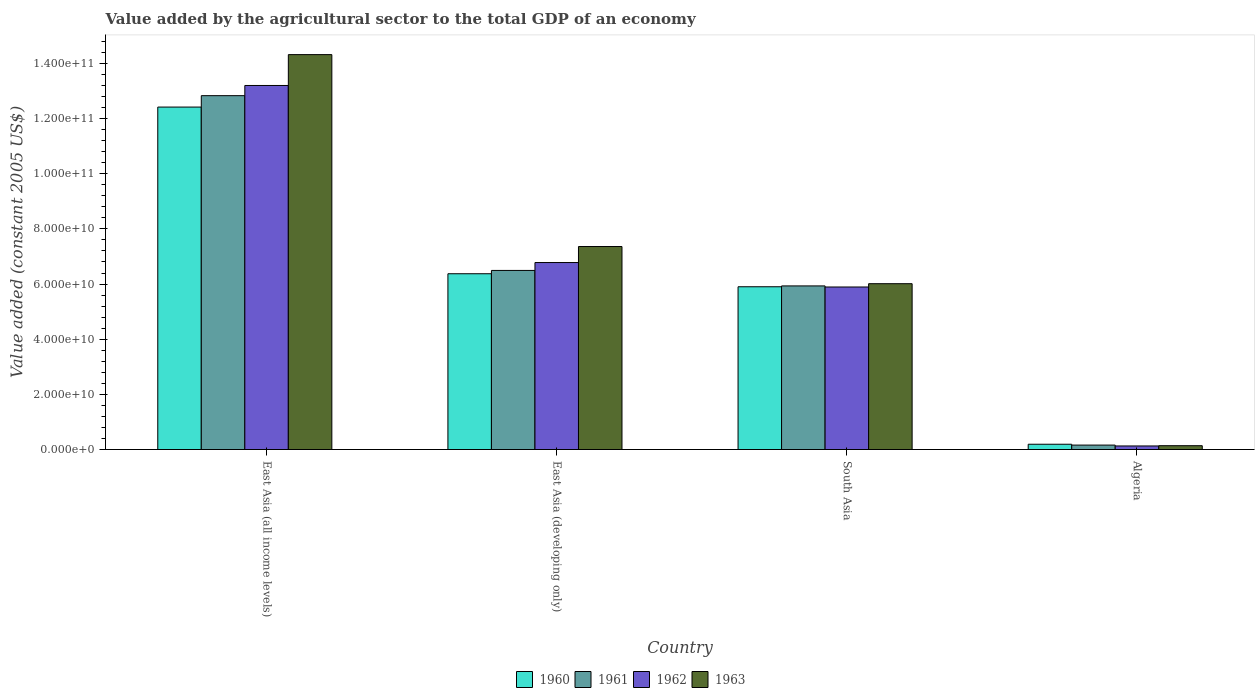Are the number of bars per tick equal to the number of legend labels?
Provide a short and direct response. Yes. What is the label of the 2nd group of bars from the left?
Your response must be concise. East Asia (developing only). In how many cases, is the number of bars for a given country not equal to the number of legend labels?
Provide a short and direct response. 0. What is the value added by the agricultural sector in 1960 in South Asia?
Your response must be concise. 5.90e+1. Across all countries, what is the maximum value added by the agricultural sector in 1961?
Offer a terse response. 1.28e+11. Across all countries, what is the minimum value added by the agricultural sector in 1961?
Ensure brevity in your answer.  1.61e+09. In which country was the value added by the agricultural sector in 1962 maximum?
Your answer should be very brief. East Asia (all income levels). In which country was the value added by the agricultural sector in 1961 minimum?
Keep it short and to the point. Algeria. What is the total value added by the agricultural sector in 1962 in the graph?
Offer a terse response. 2.60e+11. What is the difference between the value added by the agricultural sector in 1960 in East Asia (all income levels) and that in South Asia?
Your answer should be very brief. 6.51e+1. What is the difference between the value added by the agricultural sector in 1962 in East Asia (all income levels) and the value added by the agricultural sector in 1960 in East Asia (developing only)?
Your answer should be very brief. 6.83e+1. What is the average value added by the agricultural sector in 1960 per country?
Keep it short and to the point. 6.22e+1. What is the difference between the value added by the agricultural sector of/in 1963 and value added by the agricultural sector of/in 1962 in East Asia (all income levels)?
Make the answer very short. 1.12e+1. What is the ratio of the value added by the agricultural sector in 1961 in Algeria to that in South Asia?
Make the answer very short. 0.03. Is the difference between the value added by the agricultural sector in 1963 in East Asia (all income levels) and East Asia (developing only) greater than the difference between the value added by the agricultural sector in 1962 in East Asia (all income levels) and East Asia (developing only)?
Ensure brevity in your answer.  Yes. What is the difference between the highest and the second highest value added by the agricultural sector in 1960?
Offer a terse response. 6.04e+1. What is the difference between the highest and the lowest value added by the agricultural sector in 1960?
Give a very brief answer. 1.22e+11. Is it the case that in every country, the sum of the value added by the agricultural sector in 1962 and value added by the agricultural sector in 1960 is greater than the sum of value added by the agricultural sector in 1963 and value added by the agricultural sector in 1961?
Make the answer very short. No. What does the 4th bar from the left in East Asia (all income levels) represents?
Your answer should be very brief. 1963. What does the 4th bar from the right in Algeria represents?
Ensure brevity in your answer.  1960. How many bars are there?
Provide a succinct answer. 16. How many countries are there in the graph?
Make the answer very short. 4. What is the difference between two consecutive major ticks on the Y-axis?
Offer a terse response. 2.00e+1. Does the graph contain grids?
Make the answer very short. No. How many legend labels are there?
Make the answer very short. 4. What is the title of the graph?
Provide a short and direct response. Value added by the agricultural sector to the total GDP of an economy. Does "1967" appear as one of the legend labels in the graph?
Your response must be concise. No. What is the label or title of the X-axis?
Offer a very short reply. Country. What is the label or title of the Y-axis?
Your answer should be very brief. Value added (constant 2005 US$). What is the Value added (constant 2005 US$) of 1960 in East Asia (all income levels)?
Give a very brief answer. 1.24e+11. What is the Value added (constant 2005 US$) in 1961 in East Asia (all income levels)?
Make the answer very short. 1.28e+11. What is the Value added (constant 2005 US$) in 1962 in East Asia (all income levels)?
Provide a succinct answer. 1.32e+11. What is the Value added (constant 2005 US$) of 1963 in East Asia (all income levels)?
Ensure brevity in your answer.  1.43e+11. What is the Value added (constant 2005 US$) in 1960 in East Asia (developing only)?
Ensure brevity in your answer.  6.37e+1. What is the Value added (constant 2005 US$) in 1961 in East Asia (developing only)?
Offer a very short reply. 6.49e+1. What is the Value added (constant 2005 US$) in 1962 in East Asia (developing only)?
Give a very brief answer. 6.78e+1. What is the Value added (constant 2005 US$) in 1963 in East Asia (developing only)?
Offer a terse response. 7.36e+1. What is the Value added (constant 2005 US$) of 1960 in South Asia?
Ensure brevity in your answer.  5.90e+1. What is the Value added (constant 2005 US$) in 1961 in South Asia?
Make the answer very short. 5.93e+1. What is the Value added (constant 2005 US$) in 1962 in South Asia?
Provide a succinct answer. 5.89e+1. What is the Value added (constant 2005 US$) of 1963 in South Asia?
Provide a short and direct response. 6.01e+1. What is the Value added (constant 2005 US$) in 1960 in Algeria?
Give a very brief answer. 1.92e+09. What is the Value added (constant 2005 US$) of 1961 in Algeria?
Your answer should be compact. 1.61e+09. What is the Value added (constant 2005 US$) of 1962 in Algeria?
Provide a short and direct response. 1.29e+09. What is the Value added (constant 2005 US$) of 1963 in Algeria?
Offer a terse response. 1.39e+09. Across all countries, what is the maximum Value added (constant 2005 US$) in 1960?
Make the answer very short. 1.24e+11. Across all countries, what is the maximum Value added (constant 2005 US$) in 1961?
Give a very brief answer. 1.28e+11. Across all countries, what is the maximum Value added (constant 2005 US$) in 1962?
Provide a short and direct response. 1.32e+11. Across all countries, what is the maximum Value added (constant 2005 US$) of 1963?
Your answer should be very brief. 1.43e+11. Across all countries, what is the minimum Value added (constant 2005 US$) of 1960?
Your answer should be very brief. 1.92e+09. Across all countries, what is the minimum Value added (constant 2005 US$) in 1961?
Provide a succinct answer. 1.61e+09. Across all countries, what is the minimum Value added (constant 2005 US$) in 1962?
Offer a terse response. 1.29e+09. Across all countries, what is the minimum Value added (constant 2005 US$) in 1963?
Ensure brevity in your answer.  1.39e+09. What is the total Value added (constant 2005 US$) in 1960 in the graph?
Make the answer very short. 2.49e+11. What is the total Value added (constant 2005 US$) in 1961 in the graph?
Your response must be concise. 2.54e+11. What is the total Value added (constant 2005 US$) of 1962 in the graph?
Provide a succinct answer. 2.60e+11. What is the total Value added (constant 2005 US$) in 1963 in the graph?
Provide a short and direct response. 2.78e+11. What is the difference between the Value added (constant 2005 US$) in 1960 in East Asia (all income levels) and that in East Asia (developing only)?
Provide a succinct answer. 6.04e+1. What is the difference between the Value added (constant 2005 US$) in 1961 in East Asia (all income levels) and that in East Asia (developing only)?
Your answer should be very brief. 6.34e+1. What is the difference between the Value added (constant 2005 US$) of 1962 in East Asia (all income levels) and that in East Asia (developing only)?
Your answer should be compact. 6.42e+1. What is the difference between the Value added (constant 2005 US$) in 1963 in East Asia (all income levels) and that in East Asia (developing only)?
Keep it short and to the point. 6.96e+1. What is the difference between the Value added (constant 2005 US$) of 1960 in East Asia (all income levels) and that in South Asia?
Offer a very short reply. 6.51e+1. What is the difference between the Value added (constant 2005 US$) of 1961 in East Asia (all income levels) and that in South Asia?
Your response must be concise. 6.90e+1. What is the difference between the Value added (constant 2005 US$) in 1962 in East Asia (all income levels) and that in South Asia?
Your response must be concise. 7.31e+1. What is the difference between the Value added (constant 2005 US$) of 1963 in East Asia (all income levels) and that in South Asia?
Your response must be concise. 8.31e+1. What is the difference between the Value added (constant 2005 US$) of 1960 in East Asia (all income levels) and that in Algeria?
Offer a very short reply. 1.22e+11. What is the difference between the Value added (constant 2005 US$) of 1961 in East Asia (all income levels) and that in Algeria?
Keep it short and to the point. 1.27e+11. What is the difference between the Value added (constant 2005 US$) in 1962 in East Asia (all income levels) and that in Algeria?
Make the answer very short. 1.31e+11. What is the difference between the Value added (constant 2005 US$) of 1963 in East Asia (all income levels) and that in Algeria?
Your response must be concise. 1.42e+11. What is the difference between the Value added (constant 2005 US$) of 1960 in East Asia (developing only) and that in South Asia?
Your answer should be very brief. 4.72e+09. What is the difference between the Value added (constant 2005 US$) in 1961 in East Asia (developing only) and that in South Asia?
Provide a succinct answer. 5.62e+09. What is the difference between the Value added (constant 2005 US$) in 1962 in East Asia (developing only) and that in South Asia?
Ensure brevity in your answer.  8.86e+09. What is the difference between the Value added (constant 2005 US$) of 1963 in East Asia (developing only) and that in South Asia?
Your answer should be compact. 1.35e+1. What is the difference between the Value added (constant 2005 US$) of 1960 in East Asia (developing only) and that in Algeria?
Make the answer very short. 6.18e+1. What is the difference between the Value added (constant 2005 US$) of 1961 in East Asia (developing only) and that in Algeria?
Make the answer very short. 6.33e+1. What is the difference between the Value added (constant 2005 US$) of 1962 in East Asia (developing only) and that in Algeria?
Provide a short and direct response. 6.65e+1. What is the difference between the Value added (constant 2005 US$) in 1963 in East Asia (developing only) and that in Algeria?
Your answer should be compact. 7.22e+1. What is the difference between the Value added (constant 2005 US$) of 1960 in South Asia and that in Algeria?
Make the answer very short. 5.71e+1. What is the difference between the Value added (constant 2005 US$) in 1961 in South Asia and that in Algeria?
Your answer should be compact. 5.77e+1. What is the difference between the Value added (constant 2005 US$) in 1962 in South Asia and that in Algeria?
Your answer should be very brief. 5.76e+1. What is the difference between the Value added (constant 2005 US$) of 1963 in South Asia and that in Algeria?
Ensure brevity in your answer.  5.87e+1. What is the difference between the Value added (constant 2005 US$) in 1960 in East Asia (all income levels) and the Value added (constant 2005 US$) in 1961 in East Asia (developing only)?
Offer a very short reply. 5.92e+1. What is the difference between the Value added (constant 2005 US$) of 1960 in East Asia (all income levels) and the Value added (constant 2005 US$) of 1962 in East Asia (developing only)?
Offer a very short reply. 5.64e+1. What is the difference between the Value added (constant 2005 US$) in 1960 in East Asia (all income levels) and the Value added (constant 2005 US$) in 1963 in East Asia (developing only)?
Provide a short and direct response. 5.06e+1. What is the difference between the Value added (constant 2005 US$) in 1961 in East Asia (all income levels) and the Value added (constant 2005 US$) in 1962 in East Asia (developing only)?
Your answer should be very brief. 6.05e+1. What is the difference between the Value added (constant 2005 US$) in 1961 in East Asia (all income levels) and the Value added (constant 2005 US$) in 1963 in East Asia (developing only)?
Provide a short and direct response. 5.47e+1. What is the difference between the Value added (constant 2005 US$) in 1962 in East Asia (all income levels) and the Value added (constant 2005 US$) in 1963 in East Asia (developing only)?
Ensure brevity in your answer.  5.84e+1. What is the difference between the Value added (constant 2005 US$) of 1960 in East Asia (all income levels) and the Value added (constant 2005 US$) of 1961 in South Asia?
Keep it short and to the point. 6.48e+1. What is the difference between the Value added (constant 2005 US$) in 1960 in East Asia (all income levels) and the Value added (constant 2005 US$) in 1962 in South Asia?
Your answer should be compact. 6.52e+1. What is the difference between the Value added (constant 2005 US$) in 1960 in East Asia (all income levels) and the Value added (constant 2005 US$) in 1963 in South Asia?
Give a very brief answer. 6.40e+1. What is the difference between the Value added (constant 2005 US$) in 1961 in East Asia (all income levels) and the Value added (constant 2005 US$) in 1962 in South Asia?
Make the answer very short. 6.94e+1. What is the difference between the Value added (constant 2005 US$) of 1961 in East Asia (all income levels) and the Value added (constant 2005 US$) of 1963 in South Asia?
Offer a terse response. 6.82e+1. What is the difference between the Value added (constant 2005 US$) of 1962 in East Asia (all income levels) and the Value added (constant 2005 US$) of 1963 in South Asia?
Your answer should be compact. 7.19e+1. What is the difference between the Value added (constant 2005 US$) of 1960 in East Asia (all income levels) and the Value added (constant 2005 US$) of 1961 in Algeria?
Give a very brief answer. 1.23e+11. What is the difference between the Value added (constant 2005 US$) of 1960 in East Asia (all income levels) and the Value added (constant 2005 US$) of 1962 in Algeria?
Your response must be concise. 1.23e+11. What is the difference between the Value added (constant 2005 US$) in 1960 in East Asia (all income levels) and the Value added (constant 2005 US$) in 1963 in Algeria?
Your answer should be compact. 1.23e+11. What is the difference between the Value added (constant 2005 US$) of 1961 in East Asia (all income levels) and the Value added (constant 2005 US$) of 1962 in Algeria?
Provide a short and direct response. 1.27e+11. What is the difference between the Value added (constant 2005 US$) in 1961 in East Asia (all income levels) and the Value added (constant 2005 US$) in 1963 in Algeria?
Provide a short and direct response. 1.27e+11. What is the difference between the Value added (constant 2005 US$) of 1962 in East Asia (all income levels) and the Value added (constant 2005 US$) of 1963 in Algeria?
Offer a terse response. 1.31e+11. What is the difference between the Value added (constant 2005 US$) of 1960 in East Asia (developing only) and the Value added (constant 2005 US$) of 1961 in South Asia?
Make the answer very short. 4.42e+09. What is the difference between the Value added (constant 2005 US$) in 1960 in East Asia (developing only) and the Value added (constant 2005 US$) in 1962 in South Asia?
Give a very brief answer. 4.81e+09. What is the difference between the Value added (constant 2005 US$) in 1960 in East Asia (developing only) and the Value added (constant 2005 US$) in 1963 in South Asia?
Make the answer very short. 3.61e+09. What is the difference between the Value added (constant 2005 US$) in 1961 in East Asia (developing only) and the Value added (constant 2005 US$) in 1962 in South Asia?
Give a very brief answer. 6.00e+09. What is the difference between the Value added (constant 2005 US$) in 1961 in East Asia (developing only) and the Value added (constant 2005 US$) in 1963 in South Asia?
Make the answer very short. 4.81e+09. What is the difference between the Value added (constant 2005 US$) in 1962 in East Asia (developing only) and the Value added (constant 2005 US$) in 1963 in South Asia?
Your response must be concise. 7.67e+09. What is the difference between the Value added (constant 2005 US$) of 1960 in East Asia (developing only) and the Value added (constant 2005 US$) of 1961 in Algeria?
Give a very brief answer. 6.21e+1. What is the difference between the Value added (constant 2005 US$) in 1960 in East Asia (developing only) and the Value added (constant 2005 US$) in 1962 in Algeria?
Your answer should be very brief. 6.24e+1. What is the difference between the Value added (constant 2005 US$) of 1960 in East Asia (developing only) and the Value added (constant 2005 US$) of 1963 in Algeria?
Offer a terse response. 6.23e+1. What is the difference between the Value added (constant 2005 US$) in 1961 in East Asia (developing only) and the Value added (constant 2005 US$) in 1962 in Algeria?
Make the answer very short. 6.36e+1. What is the difference between the Value added (constant 2005 US$) of 1961 in East Asia (developing only) and the Value added (constant 2005 US$) of 1963 in Algeria?
Provide a short and direct response. 6.35e+1. What is the difference between the Value added (constant 2005 US$) of 1962 in East Asia (developing only) and the Value added (constant 2005 US$) of 1963 in Algeria?
Provide a short and direct response. 6.64e+1. What is the difference between the Value added (constant 2005 US$) of 1960 in South Asia and the Value added (constant 2005 US$) of 1961 in Algeria?
Your response must be concise. 5.74e+1. What is the difference between the Value added (constant 2005 US$) of 1960 in South Asia and the Value added (constant 2005 US$) of 1962 in Algeria?
Your answer should be compact. 5.77e+1. What is the difference between the Value added (constant 2005 US$) of 1960 in South Asia and the Value added (constant 2005 US$) of 1963 in Algeria?
Provide a succinct answer. 5.76e+1. What is the difference between the Value added (constant 2005 US$) of 1961 in South Asia and the Value added (constant 2005 US$) of 1962 in Algeria?
Your answer should be very brief. 5.80e+1. What is the difference between the Value added (constant 2005 US$) in 1961 in South Asia and the Value added (constant 2005 US$) in 1963 in Algeria?
Your response must be concise. 5.79e+1. What is the difference between the Value added (constant 2005 US$) in 1962 in South Asia and the Value added (constant 2005 US$) in 1963 in Algeria?
Provide a short and direct response. 5.75e+1. What is the average Value added (constant 2005 US$) in 1960 per country?
Keep it short and to the point. 6.22e+1. What is the average Value added (constant 2005 US$) in 1961 per country?
Your answer should be very brief. 6.35e+1. What is the average Value added (constant 2005 US$) of 1962 per country?
Provide a short and direct response. 6.50e+1. What is the average Value added (constant 2005 US$) in 1963 per country?
Offer a terse response. 6.96e+1. What is the difference between the Value added (constant 2005 US$) of 1960 and Value added (constant 2005 US$) of 1961 in East Asia (all income levels)?
Your answer should be compact. -4.14e+09. What is the difference between the Value added (constant 2005 US$) of 1960 and Value added (constant 2005 US$) of 1962 in East Asia (all income levels)?
Your answer should be very brief. -7.83e+09. What is the difference between the Value added (constant 2005 US$) in 1960 and Value added (constant 2005 US$) in 1963 in East Asia (all income levels)?
Make the answer very short. -1.90e+1. What is the difference between the Value added (constant 2005 US$) in 1961 and Value added (constant 2005 US$) in 1962 in East Asia (all income levels)?
Provide a succinct answer. -3.69e+09. What is the difference between the Value added (constant 2005 US$) of 1961 and Value added (constant 2005 US$) of 1963 in East Asia (all income levels)?
Make the answer very short. -1.49e+1. What is the difference between the Value added (constant 2005 US$) of 1962 and Value added (constant 2005 US$) of 1963 in East Asia (all income levels)?
Make the answer very short. -1.12e+1. What is the difference between the Value added (constant 2005 US$) in 1960 and Value added (constant 2005 US$) in 1961 in East Asia (developing only)?
Offer a very short reply. -1.20e+09. What is the difference between the Value added (constant 2005 US$) of 1960 and Value added (constant 2005 US$) of 1962 in East Asia (developing only)?
Offer a very short reply. -4.06e+09. What is the difference between the Value added (constant 2005 US$) of 1960 and Value added (constant 2005 US$) of 1963 in East Asia (developing only)?
Make the answer very short. -9.86e+09. What is the difference between the Value added (constant 2005 US$) in 1961 and Value added (constant 2005 US$) in 1962 in East Asia (developing only)?
Offer a very short reply. -2.86e+09. What is the difference between the Value added (constant 2005 US$) in 1961 and Value added (constant 2005 US$) in 1963 in East Asia (developing only)?
Give a very brief answer. -8.67e+09. What is the difference between the Value added (constant 2005 US$) of 1962 and Value added (constant 2005 US$) of 1963 in East Asia (developing only)?
Ensure brevity in your answer.  -5.81e+09. What is the difference between the Value added (constant 2005 US$) in 1960 and Value added (constant 2005 US$) in 1961 in South Asia?
Keep it short and to the point. -3.02e+08. What is the difference between the Value added (constant 2005 US$) of 1960 and Value added (constant 2005 US$) of 1962 in South Asia?
Your answer should be very brief. 8.71e+07. What is the difference between the Value added (constant 2005 US$) in 1960 and Value added (constant 2005 US$) in 1963 in South Asia?
Offer a terse response. -1.11e+09. What is the difference between the Value added (constant 2005 US$) of 1961 and Value added (constant 2005 US$) of 1962 in South Asia?
Ensure brevity in your answer.  3.89e+08. What is the difference between the Value added (constant 2005 US$) of 1961 and Value added (constant 2005 US$) of 1963 in South Asia?
Provide a succinct answer. -8.04e+08. What is the difference between the Value added (constant 2005 US$) in 1962 and Value added (constant 2005 US$) in 1963 in South Asia?
Ensure brevity in your answer.  -1.19e+09. What is the difference between the Value added (constant 2005 US$) in 1960 and Value added (constant 2005 US$) in 1961 in Algeria?
Offer a very short reply. 3.07e+08. What is the difference between the Value added (constant 2005 US$) of 1960 and Value added (constant 2005 US$) of 1962 in Algeria?
Offer a very short reply. 6.25e+08. What is the difference between the Value added (constant 2005 US$) in 1960 and Value added (constant 2005 US$) in 1963 in Algeria?
Offer a very short reply. 5.27e+08. What is the difference between the Value added (constant 2005 US$) of 1961 and Value added (constant 2005 US$) of 1962 in Algeria?
Your answer should be very brief. 3.18e+08. What is the difference between the Value added (constant 2005 US$) of 1961 and Value added (constant 2005 US$) of 1963 in Algeria?
Offer a very short reply. 2.20e+08. What is the difference between the Value added (constant 2005 US$) in 1962 and Value added (constant 2005 US$) in 1963 in Algeria?
Your answer should be compact. -9.79e+07. What is the ratio of the Value added (constant 2005 US$) in 1960 in East Asia (all income levels) to that in East Asia (developing only)?
Provide a short and direct response. 1.95. What is the ratio of the Value added (constant 2005 US$) in 1961 in East Asia (all income levels) to that in East Asia (developing only)?
Offer a very short reply. 1.98. What is the ratio of the Value added (constant 2005 US$) of 1962 in East Asia (all income levels) to that in East Asia (developing only)?
Offer a terse response. 1.95. What is the ratio of the Value added (constant 2005 US$) of 1963 in East Asia (all income levels) to that in East Asia (developing only)?
Your response must be concise. 1.95. What is the ratio of the Value added (constant 2005 US$) of 1960 in East Asia (all income levels) to that in South Asia?
Ensure brevity in your answer.  2.1. What is the ratio of the Value added (constant 2005 US$) of 1961 in East Asia (all income levels) to that in South Asia?
Give a very brief answer. 2.16. What is the ratio of the Value added (constant 2005 US$) in 1962 in East Asia (all income levels) to that in South Asia?
Offer a very short reply. 2.24. What is the ratio of the Value added (constant 2005 US$) of 1963 in East Asia (all income levels) to that in South Asia?
Offer a terse response. 2.38. What is the ratio of the Value added (constant 2005 US$) in 1960 in East Asia (all income levels) to that in Algeria?
Offer a very short reply. 64.83. What is the ratio of the Value added (constant 2005 US$) in 1961 in East Asia (all income levels) to that in Algeria?
Offer a very short reply. 79.77. What is the ratio of the Value added (constant 2005 US$) of 1962 in East Asia (all income levels) to that in Algeria?
Ensure brevity in your answer.  102.31. What is the ratio of the Value added (constant 2005 US$) in 1963 in East Asia (all income levels) to that in Algeria?
Keep it short and to the point. 103.15. What is the ratio of the Value added (constant 2005 US$) in 1960 in East Asia (developing only) to that in South Asia?
Ensure brevity in your answer.  1.08. What is the ratio of the Value added (constant 2005 US$) of 1961 in East Asia (developing only) to that in South Asia?
Provide a succinct answer. 1.09. What is the ratio of the Value added (constant 2005 US$) in 1962 in East Asia (developing only) to that in South Asia?
Give a very brief answer. 1.15. What is the ratio of the Value added (constant 2005 US$) in 1963 in East Asia (developing only) to that in South Asia?
Offer a terse response. 1.22. What is the ratio of the Value added (constant 2005 US$) in 1960 in East Asia (developing only) to that in Algeria?
Ensure brevity in your answer.  33.28. What is the ratio of the Value added (constant 2005 US$) of 1961 in East Asia (developing only) to that in Algeria?
Your answer should be very brief. 40.37. What is the ratio of the Value added (constant 2005 US$) of 1962 in East Asia (developing only) to that in Algeria?
Offer a terse response. 52.55. What is the ratio of the Value added (constant 2005 US$) in 1963 in East Asia (developing only) to that in Algeria?
Provide a succinct answer. 53.02. What is the ratio of the Value added (constant 2005 US$) in 1960 in South Asia to that in Algeria?
Your response must be concise. 30.81. What is the ratio of the Value added (constant 2005 US$) of 1961 in South Asia to that in Algeria?
Your answer should be very brief. 36.88. What is the ratio of the Value added (constant 2005 US$) in 1962 in South Asia to that in Algeria?
Provide a succinct answer. 45.68. What is the ratio of the Value added (constant 2005 US$) of 1963 in South Asia to that in Algeria?
Your answer should be very brief. 43.31. What is the difference between the highest and the second highest Value added (constant 2005 US$) of 1960?
Provide a succinct answer. 6.04e+1. What is the difference between the highest and the second highest Value added (constant 2005 US$) in 1961?
Ensure brevity in your answer.  6.34e+1. What is the difference between the highest and the second highest Value added (constant 2005 US$) of 1962?
Your answer should be compact. 6.42e+1. What is the difference between the highest and the second highest Value added (constant 2005 US$) of 1963?
Provide a short and direct response. 6.96e+1. What is the difference between the highest and the lowest Value added (constant 2005 US$) of 1960?
Provide a succinct answer. 1.22e+11. What is the difference between the highest and the lowest Value added (constant 2005 US$) of 1961?
Offer a terse response. 1.27e+11. What is the difference between the highest and the lowest Value added (constant 2005 US$) in 1962?
Your answer should be compact. 1.31e+11. What is the difference between the highest and the lowest Value added (constant 2005 US$) in 1963?
Make the answer very short. 1.42e+11. 